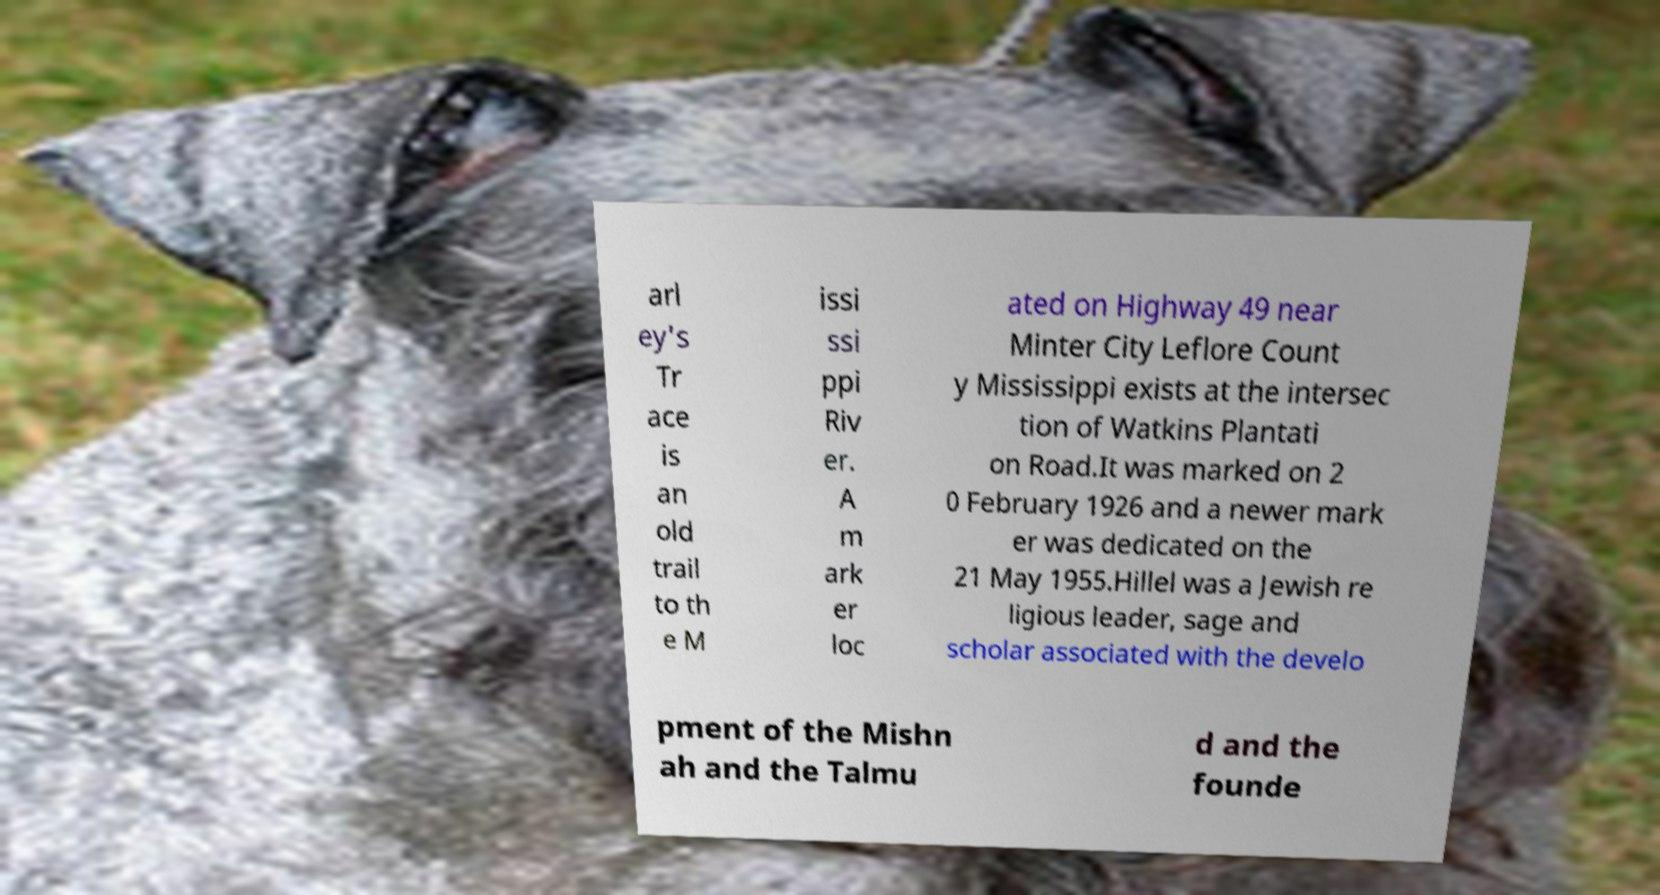What messages or text are displayed in this image? I need them in a readable, typed format. arl ey's Tr ace is an old trail to th e M issi ssi ppi Riv er. A m ark er loc ated on Highway 49 near Minter City Leflore Count y Mississippi exists at the intersec tion of Watkins Plantati on Road.It was marked on 2 0 February 1926 and a newer mark er was dedicated on the 21 May 1955.Hillel was a Jewish re ligious leader, sage and scholar associated with the develo pment of the Mishn ah and the Talmu d and the founde 